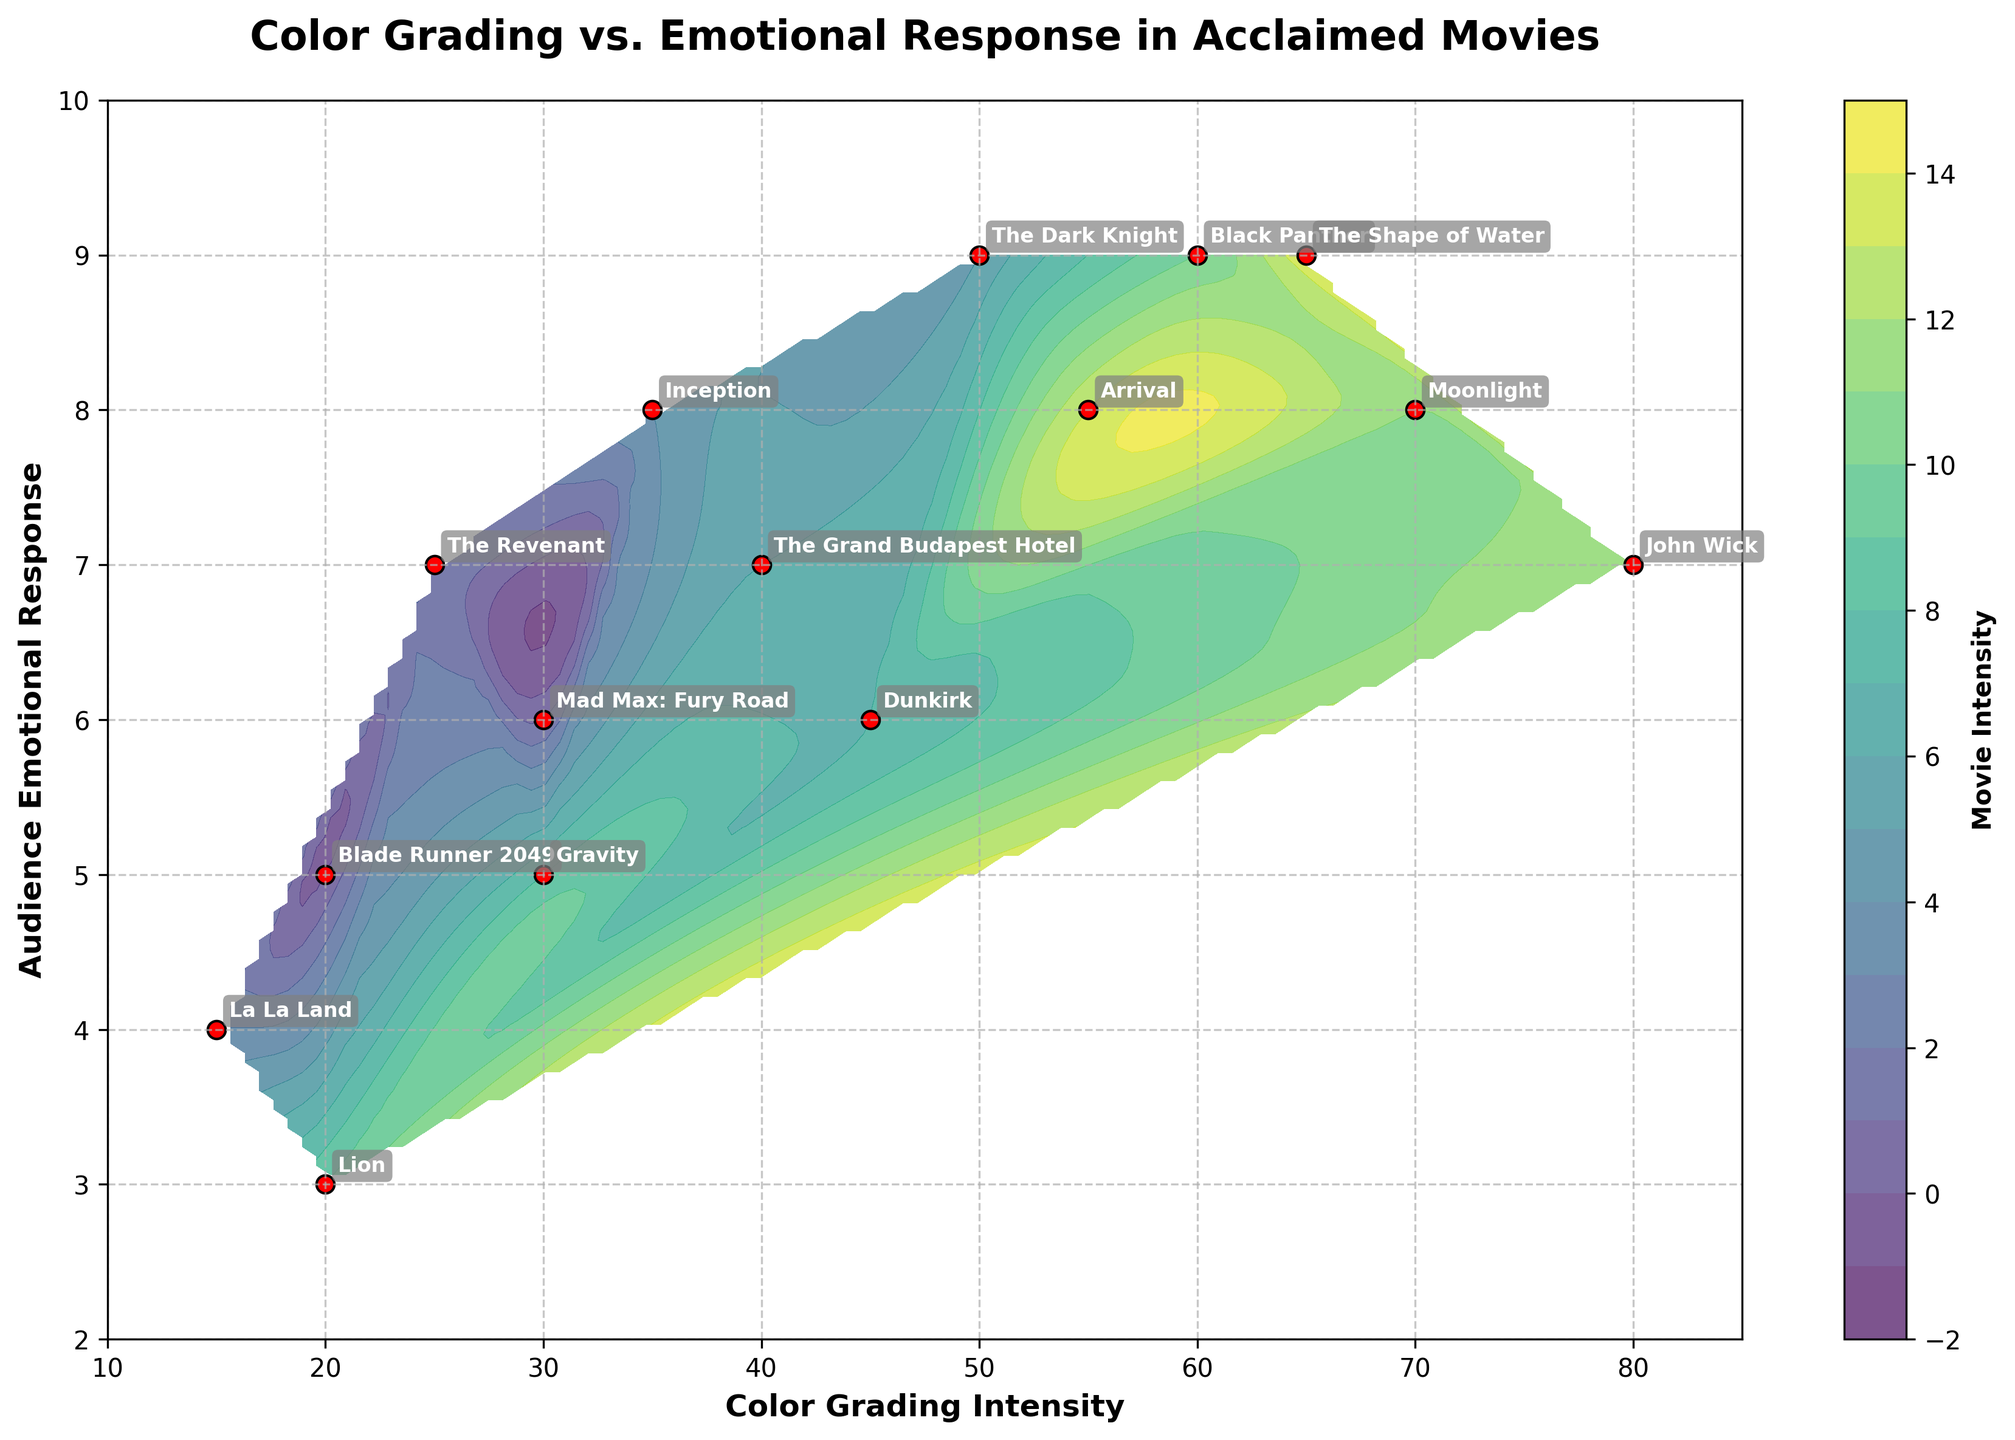What is the title of the plot? The title is usually located at the top of the plot and often summarizes what the visualization represents. Here it is clearly written at the top.
Answer: Color Grading vs. Emotional Response in Acclaimed Movies How many movies are labeled in the plot? By counting the labeled data points or annotations visible on the plot, we can determine the count of movies.
Answer: 15 Which movie corresponds to a Color Grading Intensity of 80 and an Audience Emotional Response of 7? By locating the position on the plot where the x-axis is 80 and the y-axis is 7, we find the annotation next to it.
Answer: John Wick What are the axes labels in the plot? The labels for the axes can be found along the x-axis and y-axis of the plot.
Answer: Color Grading Intensity (x-axis) and Audience Emotional Response (y-axis) Which movie has the highest Color Grading Intensity and what is the corresponding Audience Emotional Response? By identifying the point with the highest x-axis value and reading the y-axis value and annotation of that point.
Answer: Moonlight, 8 Which movie has a higher Audience Emotional Response: 'Mad Max: Fury Road' or 'Lion'? Identify the positioning of both movies on the y-axis and compare the values. 'Mad Max: Fury Road' is at 6 and 'Lion' is at 3.
Answer: Mad Max: Fury Road What is the average Color Grading Intensity of the movies 'Inception', 'The Dark Knight', and 'Dunkirk'? Identify each movie's Color Grading Intensity: 
'Inception' = 35, 'The Dark Knight' = 50, 'Dunkirk' = 45; then calculate the average (35+50+45)/3 = 43.33.
Answer: 43.33 